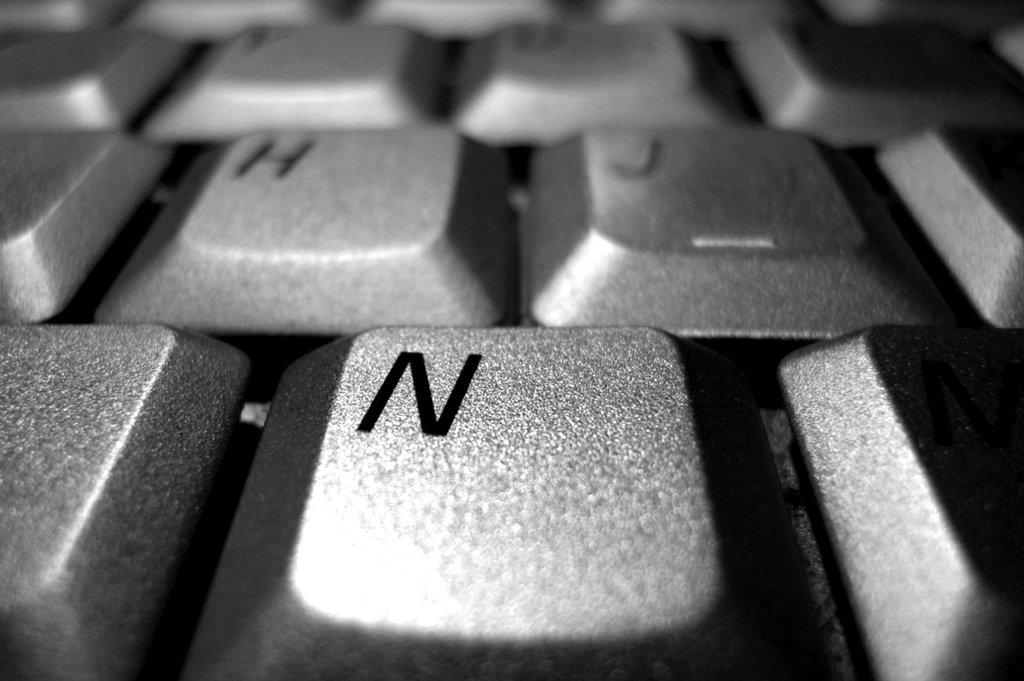<image>
Write a terse but informative summary of the picture. The main letter shown on this keyboard is N. 